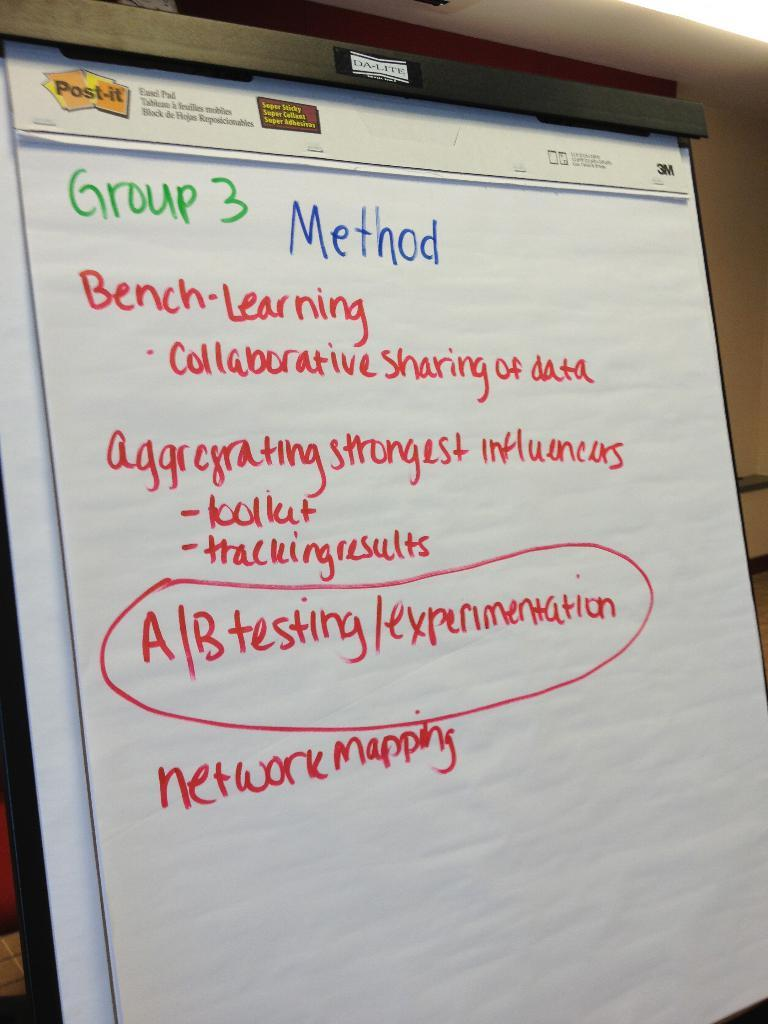<image>
Provide a brief description of the given image. A white paper board with various methods written on it. 